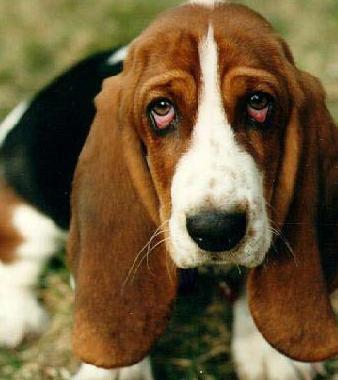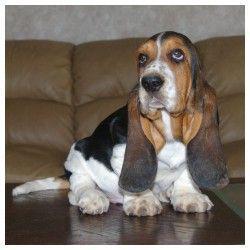The first image is the image on the left, the second image is the image on the right. Considering the images on both sides, is "Each image contains exactly one dog, and all dogs are long-eared basset hounds that gaze forward." valid? Answer yes or no. Yes. 